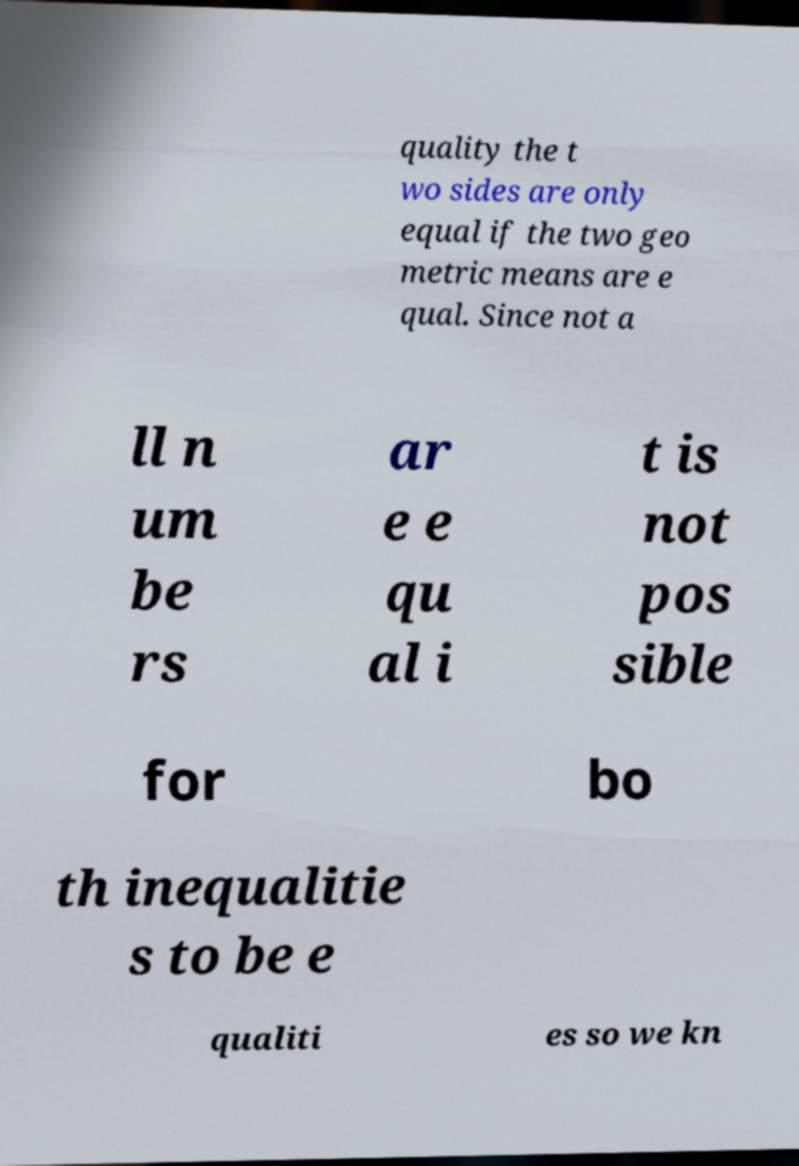I need the written content from this picture converted into text. Can you do that? quality the t wo sides are only equal if the two geo metric means are e qual. Since not a ll n um be rs ar e e qu al i t is not pos sible for bo th inequalitie s to be e qualiti es so we kn 